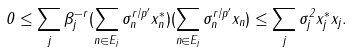<formula> <loc_0><loc_0><loc_500><loc_500>0 \leq \sum _ { j } \beta _ { j } ^ { - r } ( \sum _ { n \in E _ { j } } \sigma _ { n } ^ { r / p ^ { \prime } } x _ { n } ^ { * } ) ( \sum _ { n \in E _ { j } } \sigma _ { n } ^ { r / p ^ { \prime } } x _ { n } ) \leq \sum _ { j } \sigma _ { j } ^ { 2 } x _ { j } ^ { * } x _ { j } .</formula> 